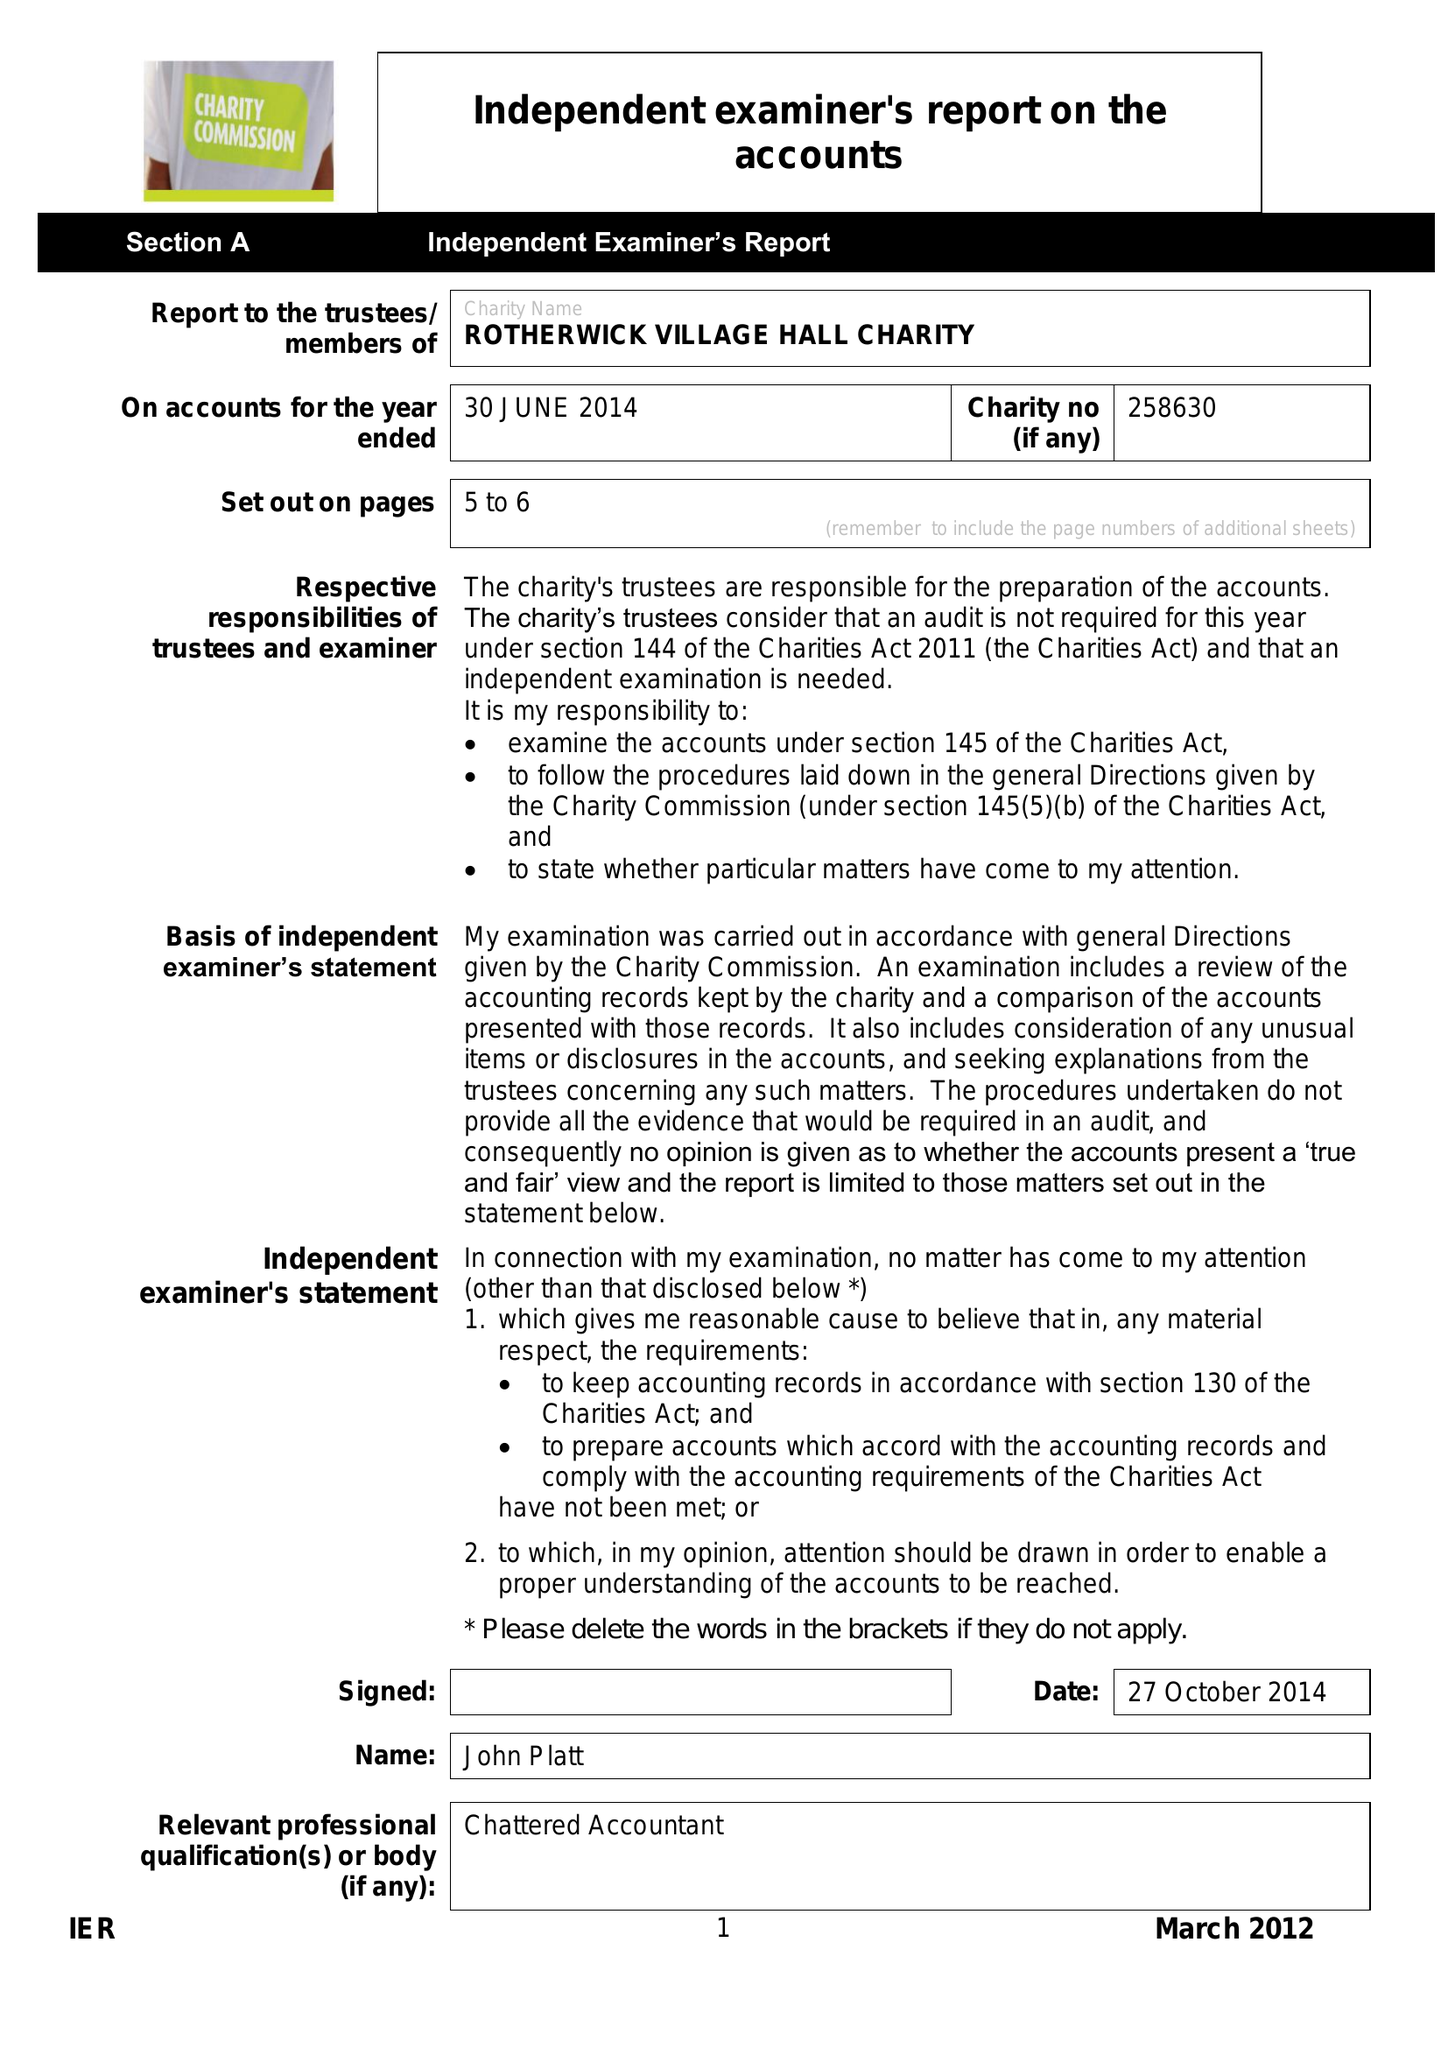What is the value for the spending_annually_in_british_pounds?
Answer the question using a single word or phrase. 65746.00 